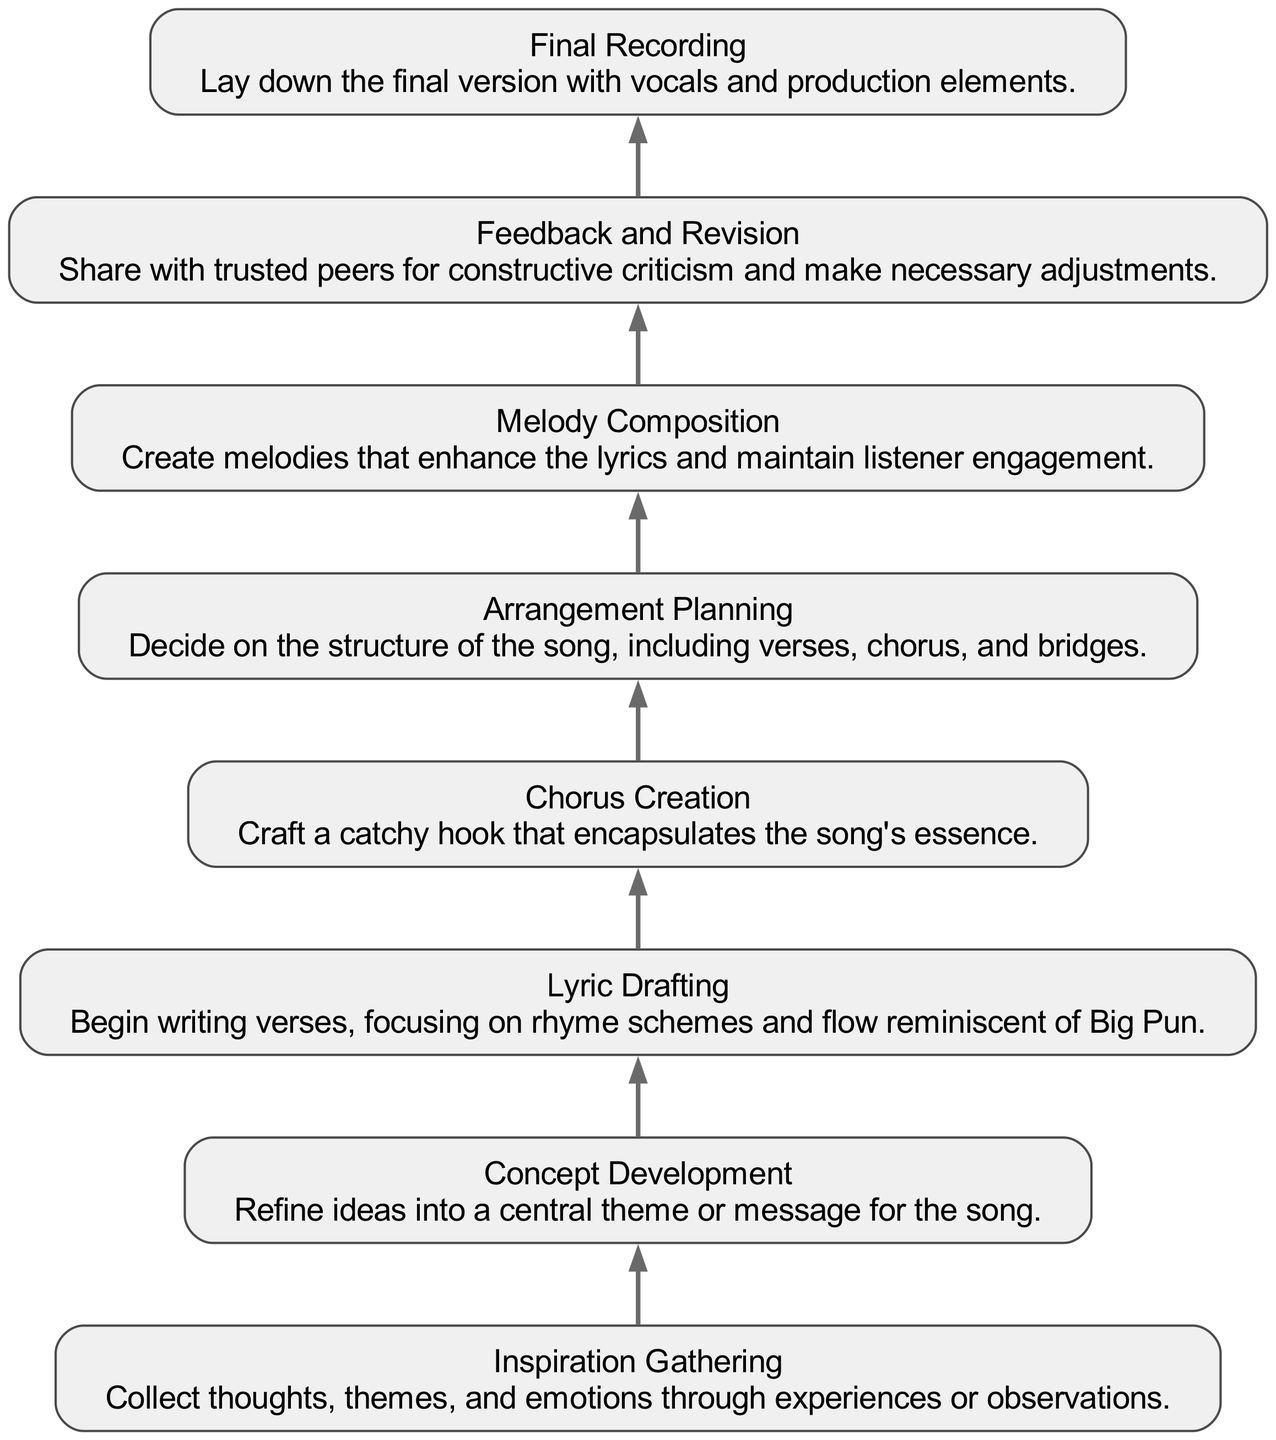What is the first step in the songwriting process? According to the diagram, the first step listed is "Inspiration Gathering." This is the initial node in the bottom-up flow chart that indicates where the process begins.
Answer: Inspiration Gathering How many total steps are in the songwriting process? The diagram lists a total of eight distinct nodes, each representing a step in the process, starting from "Inspiration Gathering" and ending with "Final Recording." Counting these nodes gives us the total number of steps.
Answer: Eight What is the last step in the diagram? The final node in the diagram is labeled "Final Recording," which signifies the completion of the songwriting process. It is positioned at the bottom in the flow chart.
Answer: Final Recording Which step follows "Chorus Creation"? The step that follows "Chorus Creation" in the flow is "Arrangement Planning." By tracing the flow from "Chorus Creation," you can see that the next node connected to it is "Arrangement Planning."
Answer: Arrangement Planning What is the relationship between "Lyric Drafting" and "Chorus Creation"? "Lyric Drafting" precedes "Chorus Creation" in the flow of the diagram, indicating that writing the verses happens before crafting the chorus. This shows a sequential relationship in the songwriting process.
Answer: Sequential Which step emphasizes feedback from peers? The step that emphasizes feedback from trusted peers is "Feedback and Revision." This is where the songwriter seeks constructive criticism to improve their work before finalizing it.
Answer: Feedback and Revision What is the main focus during "Melody Composition"? During "Melody Composition," the main focus is to create melodies that enhance the lyrics and keep the listener engaged. This highlights the importance of melody in the songwriting process.
Answer: Enhance lyrics What is the primary goal of "Concept Development"? The primary goal of "Concept Development" is to refine ideas into a central theme or message for the song. This step is crucial for establishing the song's direction.
Answer: Central theme Which node represents the creation of the song's hook? The node that represents the creation of the song's hook is "Chorus Creation." This step specifically focuses on crafting a catchy and memorable part of the song.
Answer: Chorus Creation 